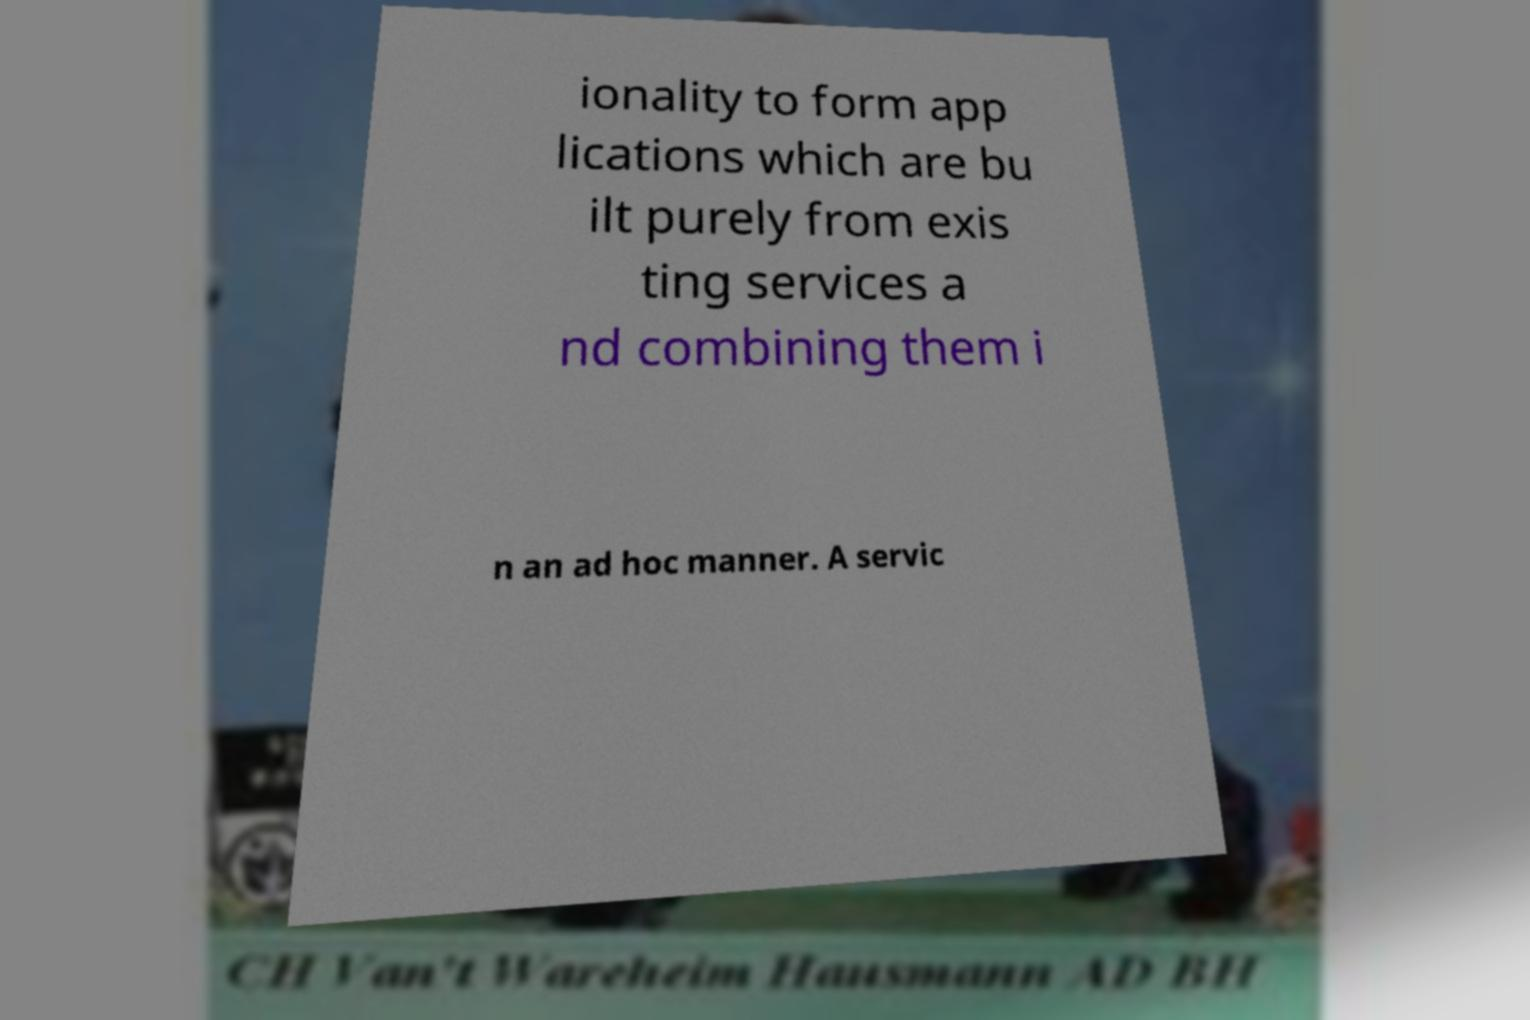Can you read and provide the text displayed in the image?This photo seems to have some interesting text. Can you extract and type it out for me? ionality to form app lications which are bu ilt purely from exis ting services a nd combining them i n an ad hoc manner. A servic 